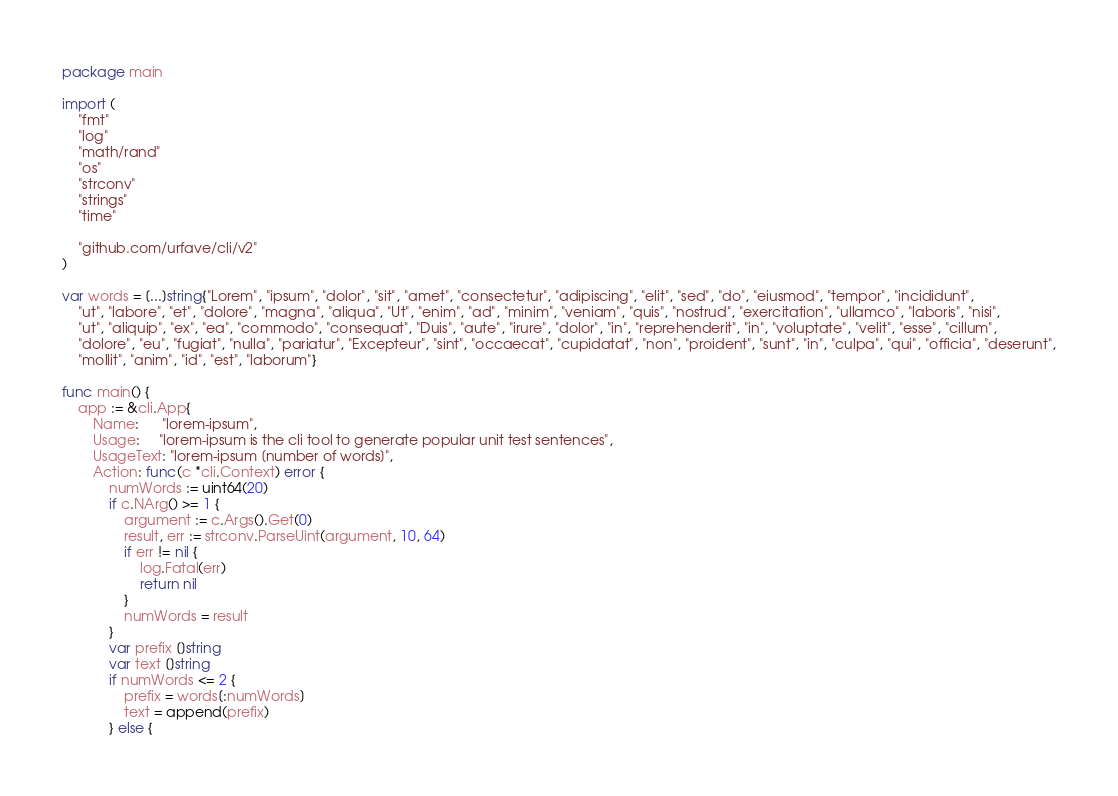<code> <loc_0><loc_0><loc_500><loc_500><_Go_>package main

import (
	"fmt"
	"log"
	"math/rand"
	"os"
	"strconv"
	"strings"
	"time"

	"github.com/urfave/cli/v2"
)

var words = [...]string{"Lorem", "ipsum", "dolor", "sit", "amet", "consectetur", "adipiscing", "elit", "sed", "do", "eiusmod", "tempor", "incididunt",
	"ut", "labore", "et", "dolore", "magna", "aliqua", "Ut", "enim", "ad", "minim", "veniam", "quis", "nostrud", "exercitation", "ullamco", "laboris", "nisi",
	"ut", "aliquip", "ex", "ea", "commodo", "consequat", "Duis", "aute", "irure", "dolor", "in", "reprehenderit", "in", "voluptate", "velit", "esse", "cillum",
	"dolore", "eu", "fugiat", "nulla", "pariatur", "Excepteur", "sint", "occaecat", "cupidatat", "non", "proident", "sunt", "in", "culpa", "qui", "officia", "deserunt",
	"mollit", "anim", "id", "est", "laborum"}

func main() {
	app := &cli.App{
		Name:      "lorem-ipsum",
		Usage:     "lorem-ipsum is the cli tool to generate popular unit test sentences",
		UsageText: "lorem-ipsum [number of words]",
		Action: func(c *cli.Context) error {
			numWords := uint64(20)
			if c.NArg() >= 1 {
				argument := c.Args().Get(0)
				result, err := strconv.ParseUint(argument, 10, 64)
				if err != nil {
					log.Fatal(err)
					return nil
				}
				numWords = result
			}
			var prefix []string
			var text []string
			if numWords <= 2 {
				prefix = words[:numWords]
				text = append(prefix)
			} else {</code> 